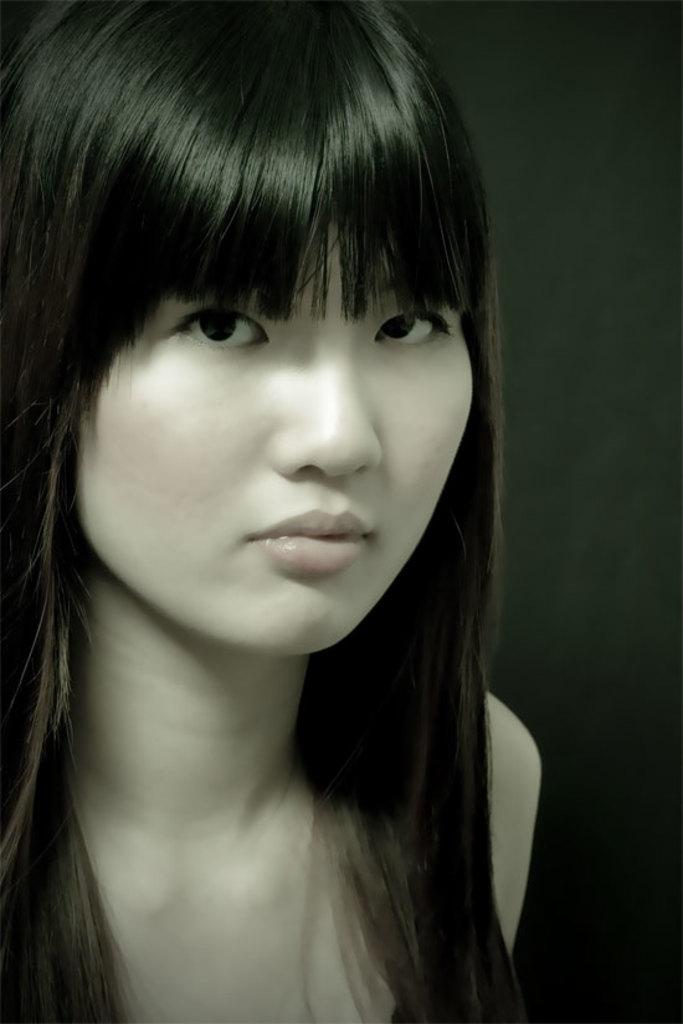Who is the main subject in the image? There is a girl in the image. What can be seen in the background of the image? The background of the image is black. What type of wax is being used for teaching in the image? There is no wax or teaching activity present in the image. 